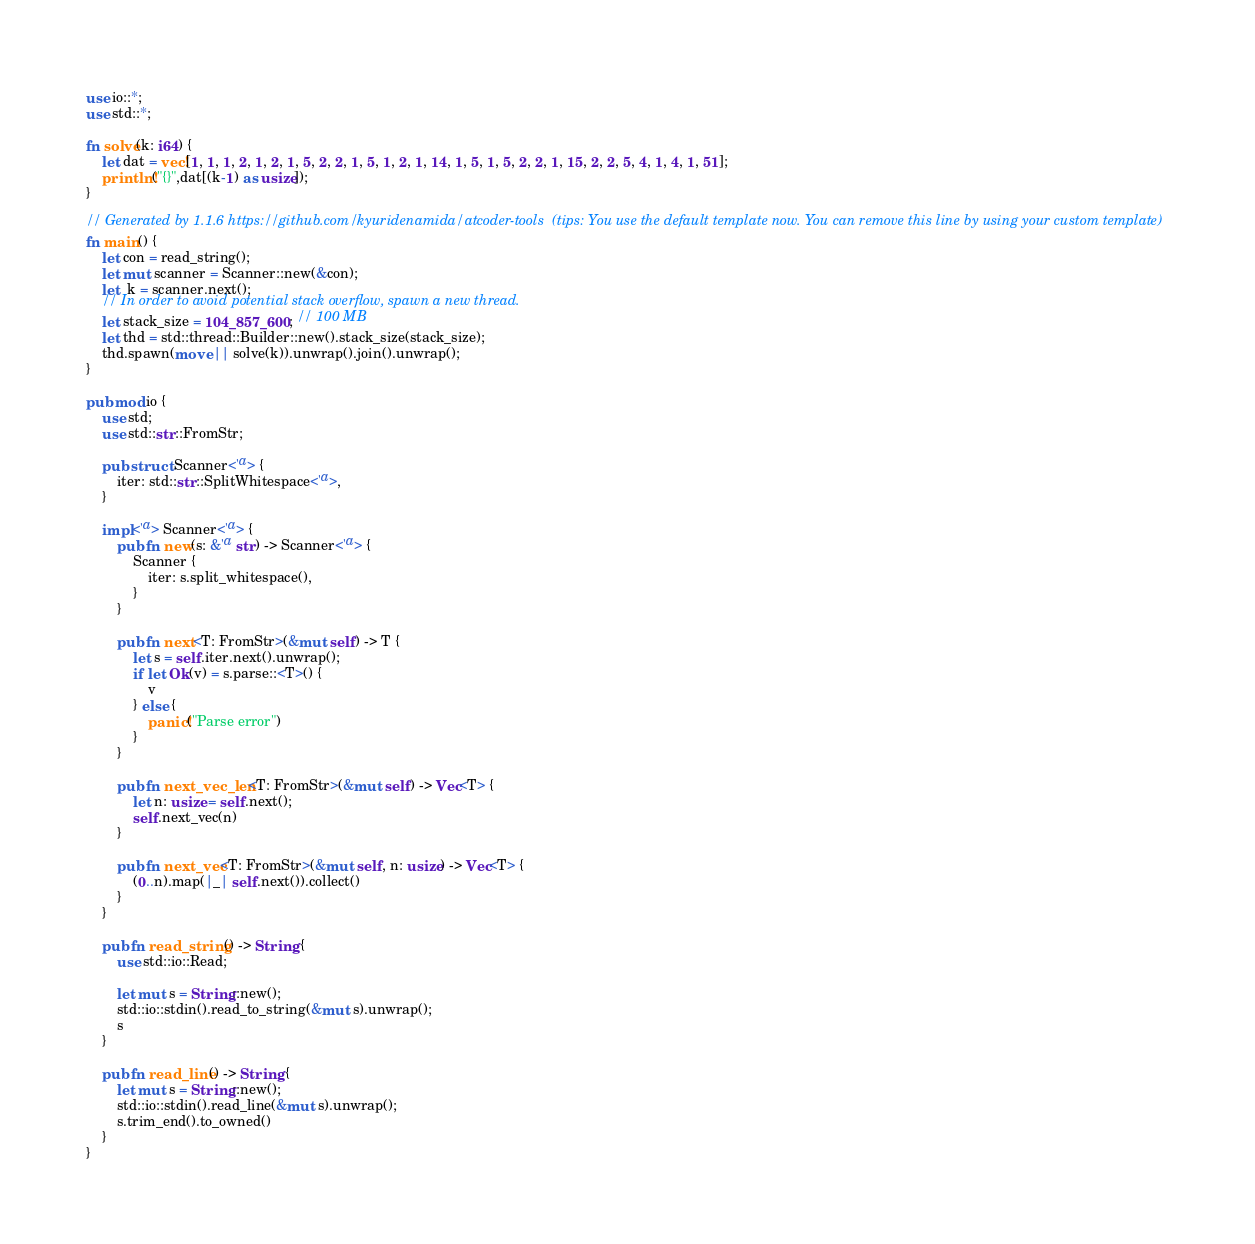Convert code to text. <code><loc_0><loc_0><loc_500><loc_500><_Rust_>use io::*;
use std::*;

fn solve(k: i64) {
    let dat = vec![1, 1, 1, 2, 1, 2, 1, 5, 2, 2, 1, 5, 1, 2, 1, 14, 1, 5, 1, 5, 2, 2, 1, 15, 2, 2, 5, 4, 1, 4, 1, 51];
    println!("{}",dat[(k-1) as usize]);
}

// Generated by 1.1.6 https://github.com/kyuridenamida/atcoder-tools  (tips: You use the default template now. You can remove this line by using your custom template)
fn main() {
    let con = read_string();
    let mut scanner = Scanner::new(&con);
    let  k = scanner.next();
    // In order to avoid potential stack overflow, spawn a new thread.
    let stack_size = 104_857_600; // 100 MB
    let thd = std::thread::Builder::new().stack_size(stack_size);
    thd.spawn(move || solve(k)).unwrap().join().unwrap();
}

pub mod io {
    use std;
    use std::str::FromStr;

    pub struct Scanner<'a> {
        iter: std::str::SplitWhitespace<'a>,
    }

    impl<'a> Scanner<'a> {
        pub fn new(s: &'a str) -> Scanner<'a> {
            Scanner {
                iter: s.split_whitespace(),
            }
        }

        pub fn next<T: FromStr>(&mut self) -> T {
            let s = self.iter.next().unwrap();
            if let Ok(v) = s.parse::<T>() {
                v
            } else {
                panic!("Parse error")
            }
        }

        pub fn next_vec_len<T: FromStr>(&mut self) -> Vec<T> {
            let n: usize = self.next();
            self.next_vec(n)
        }

        pub fn next_vec<T: FromStr>(&mut self, n: usize) -> Vec<T> {
            (0..n).map(|_| self.next()).collect()
        }
    }

    pub fn read_string() -> String {
        use std::io::Read;

        let mut s = String::new();
        std::io::stdin().read_to_string(&mut s).unwrap();
        s
    }

    pub fn read_line() -> String {
        let mut s = String::new();
        std::io::stdin().read_line(&mut s).unwrap();
        s.trim_end().to_owned()
    }
}
</code> 